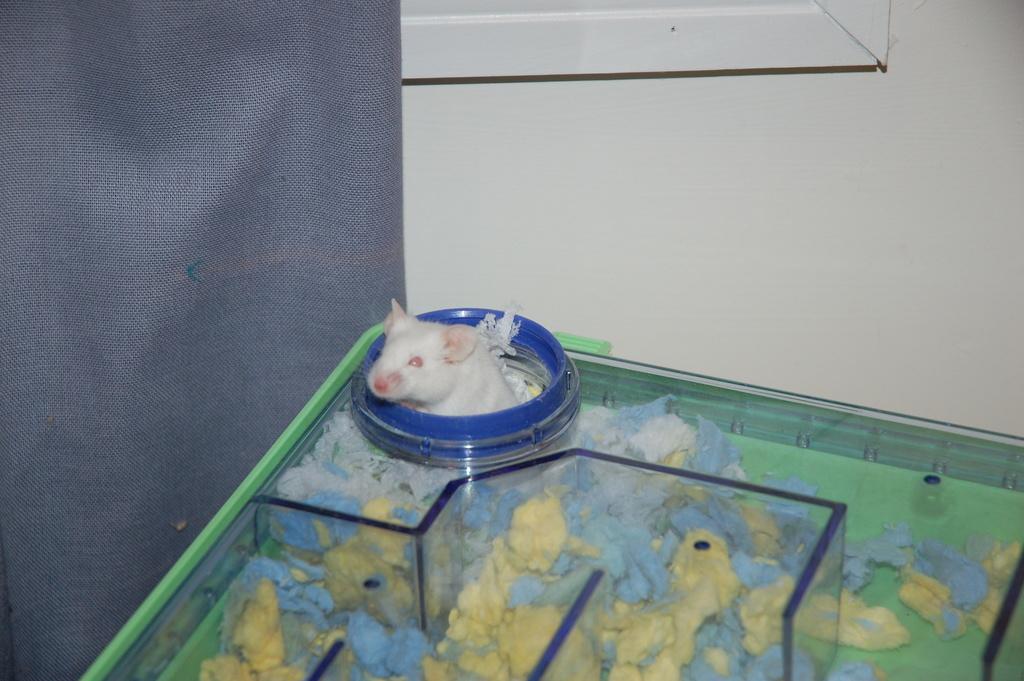Could you give a brief overview of what you see in this image? At the bottom of the image there is a table, on the table there is a rat. Behind the table there is a wall and cloth. 